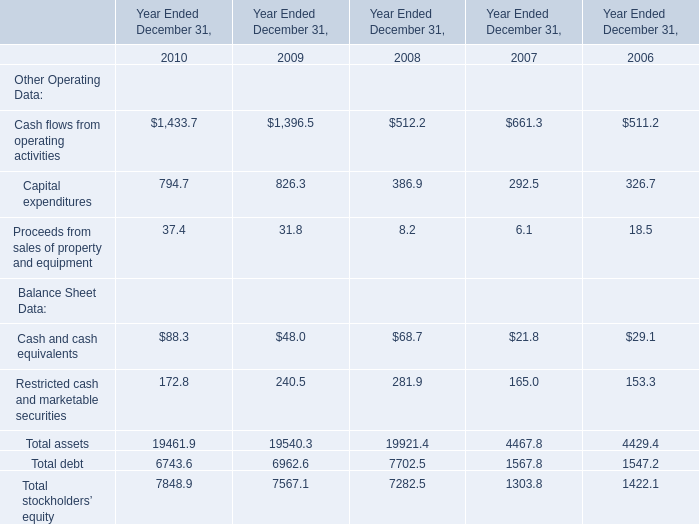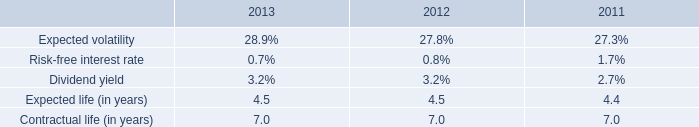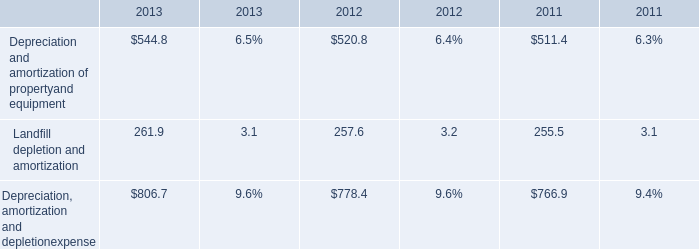what was the growth of the weighted-average estimated fair values of stock options granted from 2012 to 2013 
Computations: ((5.27 - 4.77) / 4.77)
Answer: 0.10482. 